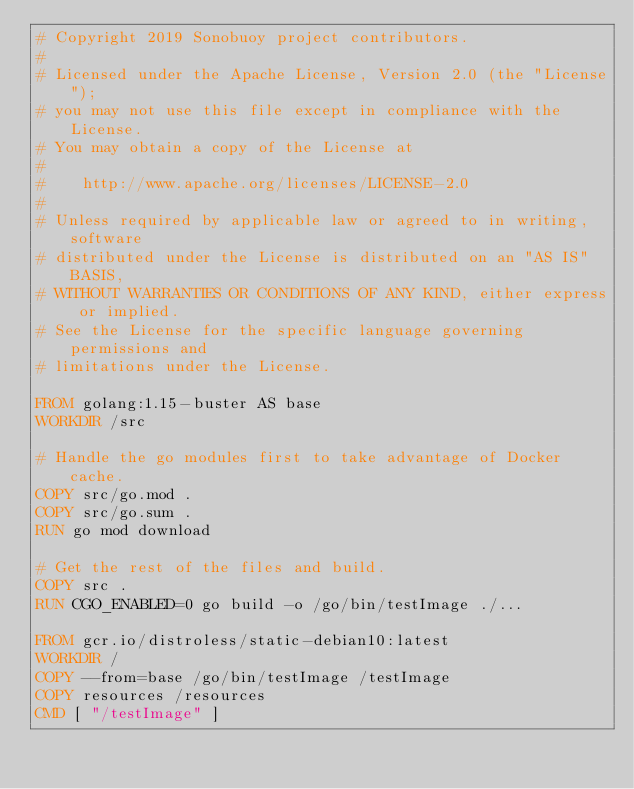<code> <loc_0><loc_0><loc_500><loc_500><_Dockerfile_># Copyright 2019 Sonobuoy project contributors.
#
# Licensed under the Apache License, Version 2.0 (the "License");
# you may not use this file except in compliance with the License.
# You may obtain a copy of the License at
#
#    http://www.apache.org/licenses/LICENSE-2.0
#
# Unless required by applicable law or agreed to in writing, software
# distributed under the License is distributed on an "AS IS" BASIS,
# WITHOUT WARRANTIES OR CONDITIONS OF ANY KIND, either express or implied.
# See the License for the specific language governing permissions and
# limitations under the License.

FROM golang:1.15-buster AS base
WORKDIR /src

# Handle the go modules first to take advantage of Docker cache.
COPY src/go.mod .
COPY src/go.sum .
RUN go mod download

# Get the rest of the files and build.
COPY src .
RUN CGO_ENABLED=0 go build -o /go/bin/testImage ./...

FROM gcr.io/distroless/static-debian10:latest
WORKDIR /
COPY --from=base /go/bin/testImage /testImage
COPY resources /resources
CMD [ "/testImage" ]

</code> 